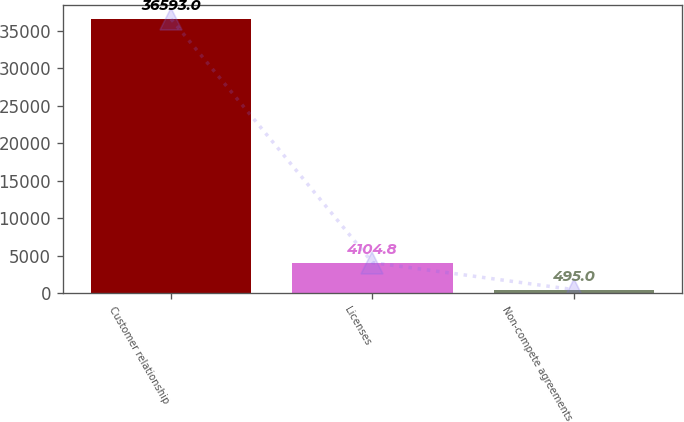Convert chart to OTSL. <chart><loc_0><loc_0><loc_500><loc_500><bar_chart><fcel>Customer relationship<fcel>Licenses<fcel>Non-compete agreements<nl><fcel>36593<fcel>4104.8<fcel>495<nl></chart> 